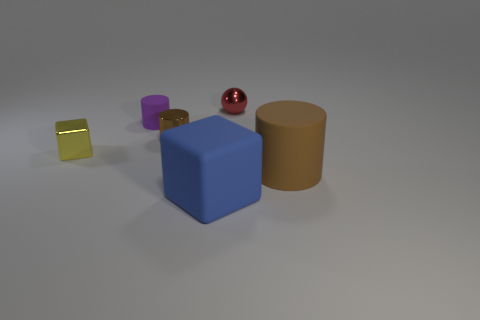Considering the lighting in the scene, where do you think the light source is located? Based on the shadows and highlights, the light source appears to be coming from the top left corner of the image, casting shadows to the right of the objects. 